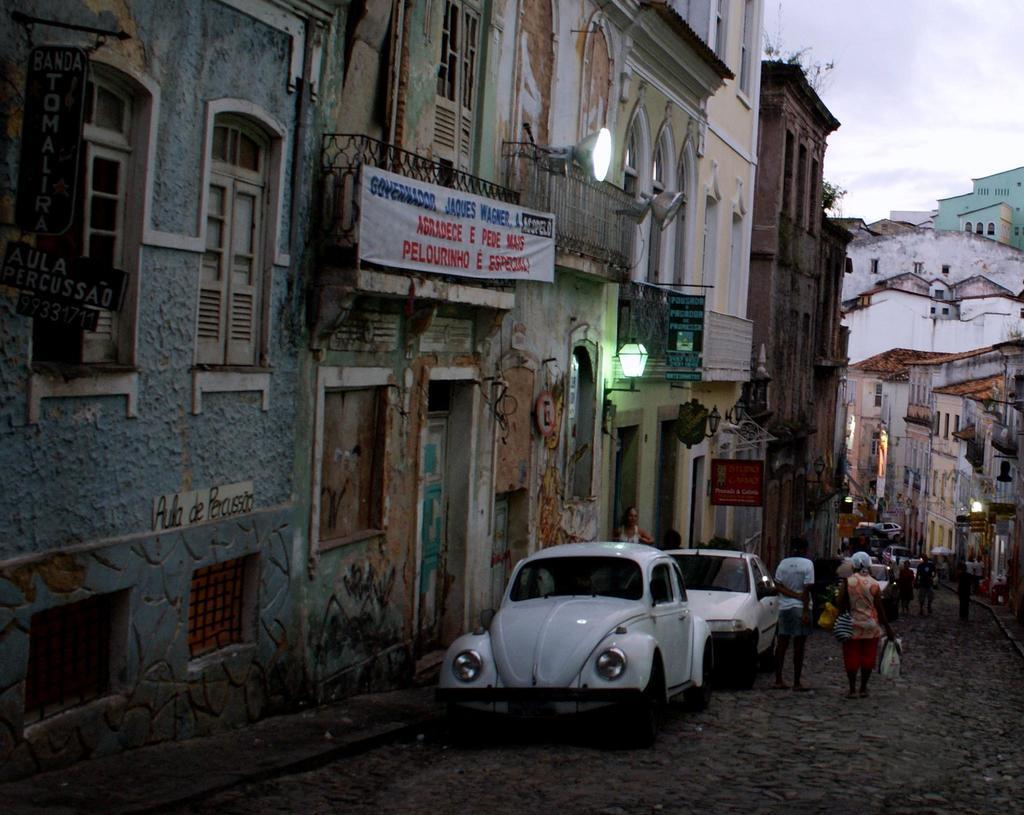Can you describe this image briefly? In this image there are cars on a road and people walking, on either side of the road there are houses, in the background there is the sky. 